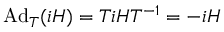<formula> <loc_0><loc_0><loc_500><loc_500>A d _ { T } ( i H ) = T i H T ^ { - 1 } = - i H</formula> 